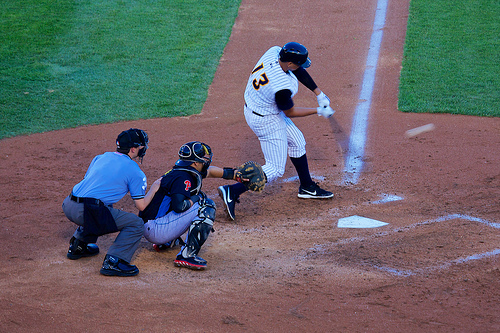On which side is the umpire? The umpire is standing to the left behind the catcher, overseeing the game. 